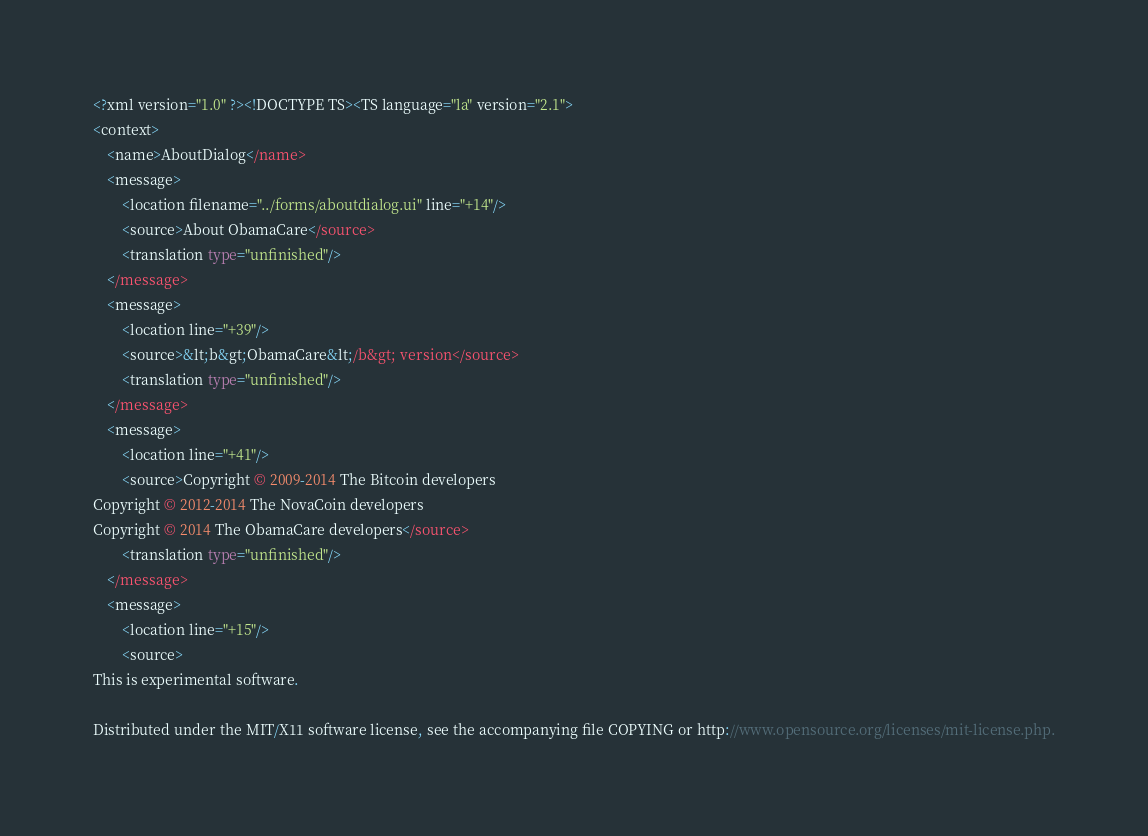<code> <loc_0><loc_0><loc_500><loc_500><_TypeScript_><?xml version="1.0" ?><!DOCTYPE TS><TS language="la" version="2.1">
<context>
    <name>AboutDialog</name>
    <message>
        <location filename="../forms/aboutdialog.ui" line="+14"/>
        <source>About ObamaCare</source>
        <translation type="unfinished"/>
    </message>
    <message>
        <location line="+39"/>
        <source>&lt;b&gt;ObamaCare&lt;/b&gt; version</source>
        <translation type="unfinished"/>
    </message>
    <message>
        <location line="+41"/>
        <source>Copyright © 2009-2014 The Bitcoin developers
Copyright © 2012-2014 The NovaCoin developers
Copyright © 2014 The ObamaCare developers</source>
        <translation type="unfinished"/>
    </message>
    <message>
        <location line="+15"/>
        <source>
This is experimental software.

Distributed under the MIT/X11 software license, see the accompanying file COPYING or http://www.opensource.org/licenses/mit-license.php.
</code> 